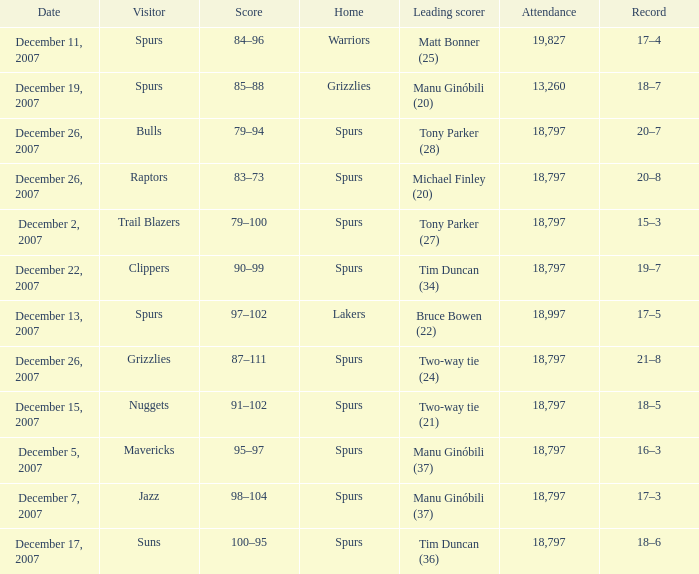What is the highest attendace of the game with the Lakers as the home team? 18997.0. 